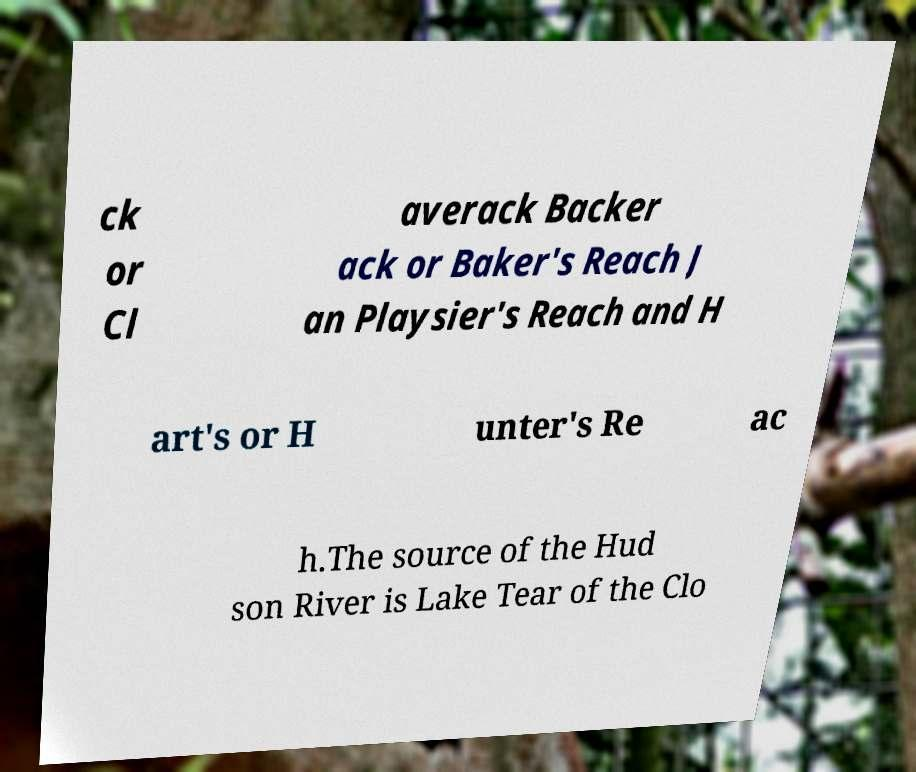For documentation purposes, I need the text within this image transcribed. Could you provide that? ck or Cl averack Backer ack or Baker's Reach J an Playsier's Reach and H art's or H unter's Re ac h.The source of the Hud son River is Lake Tear of the Clo 